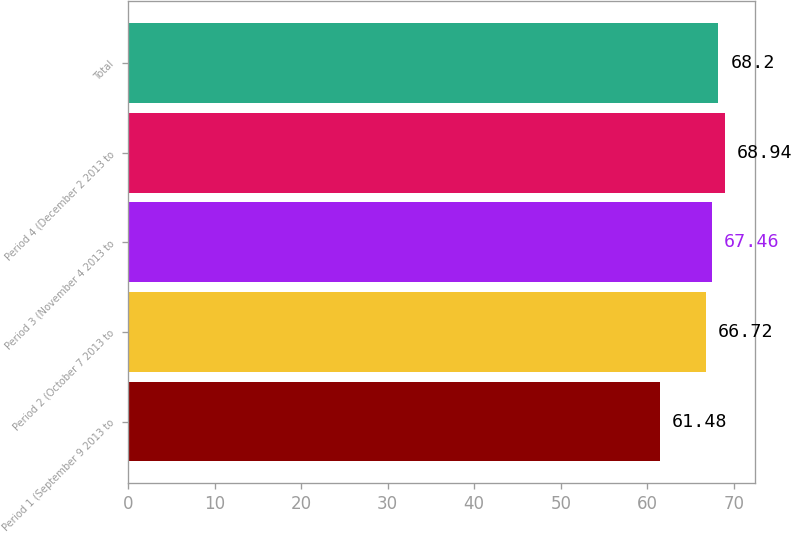Convert chart to OTSL. <chart><loc_0><loc_0><loc_500><loc_500><bar_chart><fcel>Period 1 (September 9 2013 to<fcel>Period 2 (October 7 2013 to<fcel>Period 3 (November 4 2013 to<fcel>Period 4 (December 2 2013 to<fcel>Total<nl><fcel>61.48<fcel>66.72<fcel>67.46<fcel>68.94<fcel>68.2<nl></chart> 